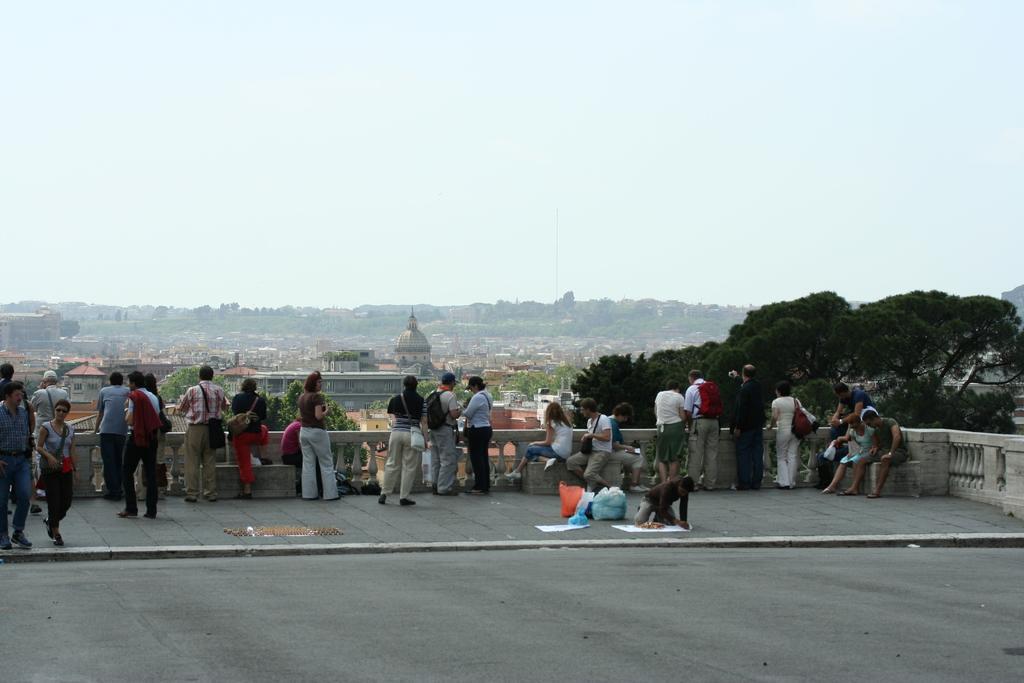Please provide a concise description of this image. In the picture we can see some group of persons standing on floor and in the background of the picture there are some trees, houses and there is clear sky. 